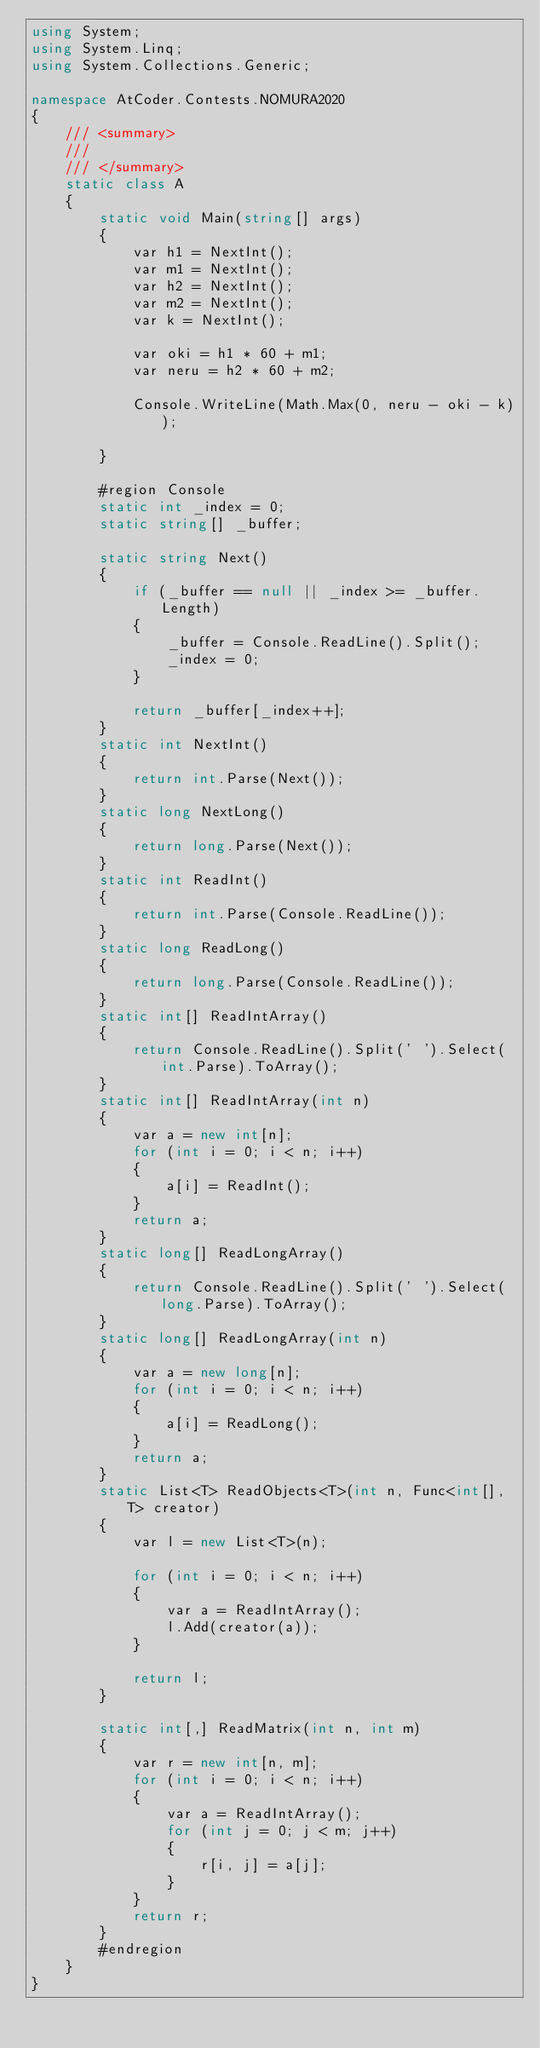Convert code to text. <code><loc_0><loc_0><loc_500><loc_500><_C#_>using System;
using System.Linq;
using System.Collections.Generic;

namespace AtCoder.Contests.NOMURA2020
{
    /// <summary>
    /// 
    /// </summary>
    static class A
    {
        static void Main(string[] args)
        {
            var h1 = NextInt();
            var m1 = NextInt();
            var h2 = NextInt();
            var m2 = NextInt();
            var k = NextInt();

            var oki = h1 * 60 + m1;
            var neru = h2 * 60 + m2;

            Console.WriteLine(Math.Max(0, neru - oki - k));

        }

        #region Console
        static int _index = 0;
        static string[] _buffer;

        static string Next()
        {
            if (_buffer == null || _index >= _buffer.Length)
            {
                _buffer = Console.ReadLine().Split();
                _index = 0;
            }

            return _buffer[_index++];
        }
        static int NextInt()
        {
            return int.Parse(Next());
        }
        static long NextLong()
        {
            return long.Parse(Next());
        }
        static int ReadInt()
        {
            return int.Parse(Console.ReadLine());
        }
        static long ReadLong()
        {
            return long.Parse(Console.ReadLine());
        }
        static int[] ReadIntArray()
        {
            return Console.ReadLine().Split(' ').Select(int.Parse).ToArray();
        }
        static int[] ReadIntArray(int n)
        {
            var a = new int[n];
            for (int i = 0; i < n; i++)
            {
                a[i] = ReadInt();
            }
            return a;
        }
        static long[] ReadLongArray()
        {
            return Console.ReadLine().Split(' ').Select(long.Parse).ToArray();
        }
        static long[] ReadLongArray(int n)
        {
            var a = new long[n];
            for (int i = 0; i < n; i++)
            {
                a[i] = ReadLong();
            }
            return a;
        }
        static List<T> ReadObjects<T>(int n, Func<int[], T> creator)
        {
            var l = new List<T>(n);

            for (int i = 0; i < n; i++)
            {
                var a = ReadIntArray();
                l.Add(creator(a));
            }

            return l;
        }

        static int[,] ReadMatrix(int n, int m)
        {
            var r = new int[n, m];
            for (int i = 0; i < n; i++)
            {
                var a = ReadIntArray();
                for (int j = 0; j < m; j++)
                {
                    r[i, j] = a[j];
                }
            }
            return r;
        }
        #endregion
    }
}
</code> 